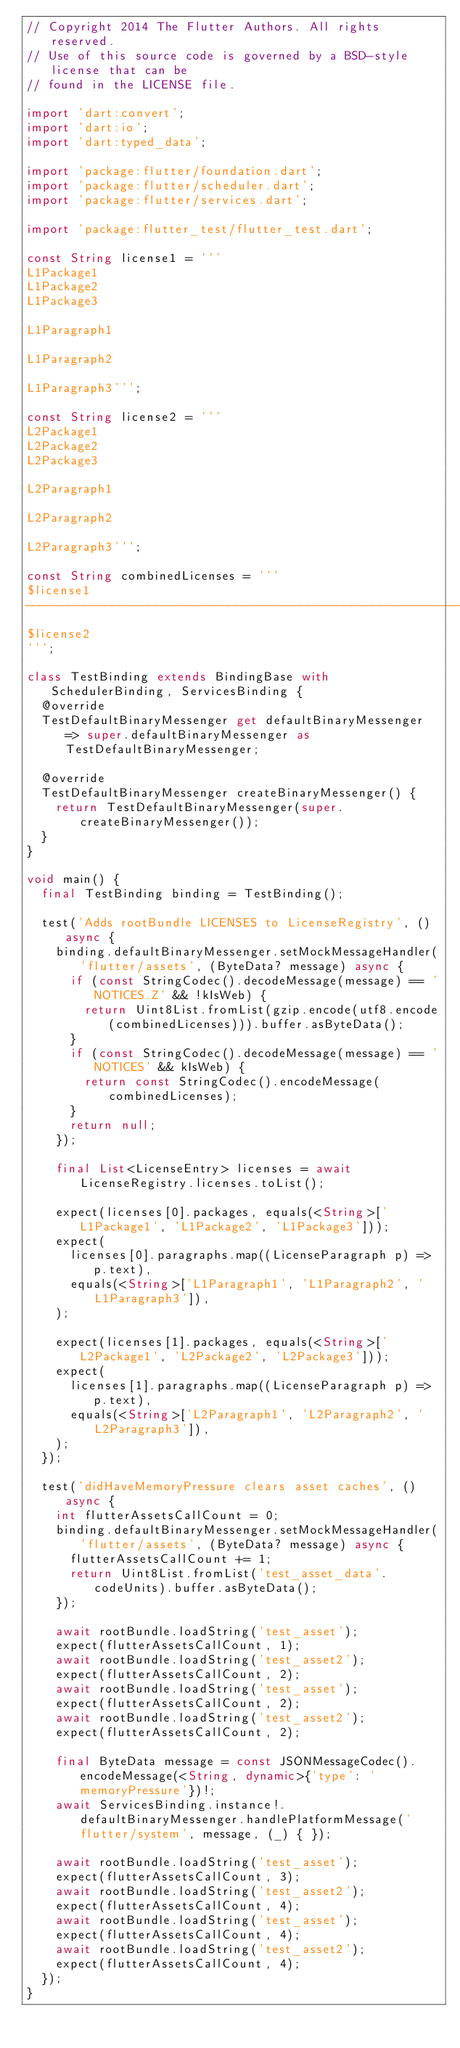<code> <loc_0><loc_0><loc_500><loc_500><_Dart_>// Copyright 2014 The Flutter Authors. All rights reserved.
// Use of this source code is governed by a BSD-style license that can be
// found in the LICENSE file.

import 'dart:convert';
import 'dart:io';
import 'dart:typed_data';

import 'package:flutter/foundation.dart';
import 'package:flutter/scheduler.dart';
import 'package:flutter/services.dart';

import 'package:flutter_test/flutter_test.dart';

const String license1 = '''
L1Package1
L1Package2
L1Package3

L1Paragraph1

L1Paragraph2

L1Paragraph3''';

const String license2 = '''
L2Package1
L2Package2
L2Package3

L2Paragraph1

L2Paragraph2

L2Paragraph3''';

const String combinedLicenses = '''
$license1
--------------------------------------------------------------------------------
$license2
''';

class TestBinding extends BindingBase with SchedulerBinding, ServicesBinding {
  @override
  TestDefaultBinaryMessenger get defaultBinaryMessenger => super.defaultBinaryMessenger as TestDefaultBinaryMessenger;

  @override
  TestDefaultBinaryMessenger createBinaryMessenger() {
    return TestDefaultBinaryMessenger(super.createBinaryMessenger());
  }
}

void main() {
  final TestBinding binding = TestBinding();

  test('Adds rootBundle LICENSES to LicenseRegistry', () async {
    binding.defaultBinaryMessenger.setMockMessageHandler('flutter/assets', (ByteData? message) async {
      if (const StringCodec().decodeMessage(message) == 'NOTICES.Z' && !kIsWeb) {
        return Uint8List.fromList(gzip.encode(utf8.encode(combinedLicenses))).buffer.asByteData();
      }
      if (const StringCodec().decodeMessage(message) == 'NOTICES' && kIsWeb) {
        return const StringCodec().encodeMessage(combinedLicenses);
      }
      return null;
    });

    final List<LicenseEntry> licenses = await LicenseRegistry.licenses.toList();

    expect(licenses[0].packages, equals(<String>['L1Package1', 'L1Package2', 'L1Package3']));
    expect(
      licenses[0].paragraphs.map((LicenseParagraph p) => p.text),
      equals(<String>['L1Paragraph1', 'L1Paragraph2', 'L1Paragraph3']),
    );

    expect(licenses[1].packages, equals(<String>['L2Package1', 'L2Package2', 'L2Package3']));
    expect(
      licenses[1].paragraphs.map((LicenseParagraph p) => p.text),
      equals(<String>['L2Paragraph1', 'L2Paragraph2', 'L2Paragraph3']),
    );
  });

  test('didHaveMemoryPressure clears asset caches', () async {
    int flutterAssetsCallCount = 0;
    binding.defaultBinaryMessenger.setMockMessageHandler('flutter/assets', (ByteData? message) async {
      flutterAssetsCallCount += 1;
      return Uint8List.fromList('test_asset_data'.codeUnits).buffer.asByteData();
    });

    await rootBundle.loadString('test_asset');
    expect(flutterAssetsCallCount, 1);
    await rootBundle.loadString('test_asset2');
    expect(flutterAssetsCallCount, 2);
    await rootBundle.loadString('test_asset');
    expect(flutterAssetsCallCount, 2);
    await rootBundle.loadString('test_asset2');
    expect(flutterAssetsCallCount, 2);

    final ByteData message = const JSONMessageCodec().encodeMessage(<String, dynamic>{'type': 'memoryPressure'})!;
    await ServicesBinding.instance!.defaultBinaryMessenger.handlePlatformMessage('flutter/system', message, (_) { });

    await rootBundle.loadString('test_asset');
    expect(flutterAssetsCallCount, 3);
    await rootBundle.loadString('test_asset2');
    expect(flutterAssetsCallCount, 4);
    await rootBundle.loadString('test_asset');
    expect(flutterAssetsCallCount, 4);
    await rootBundle.loadString('test_asset2');
    expect(flutterAssetsCallCount, 4);
  });
}
</code> 